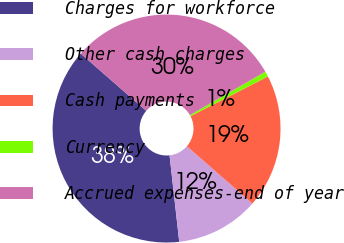Convert chart to OTSL. <chart><loc_0><loc_0><loc_500><loc_500><pie_chart><fcel>Charges for workforce<fcel>Other cash charges<fcel>Cash payments<fcel>Currency<fcel>Accrued expenses-end of year<nl><fcel>38.2%<fcel>11.8%<fcel>18.99%<fcel>0.75%<fcel>30.26%<nl></chart> 